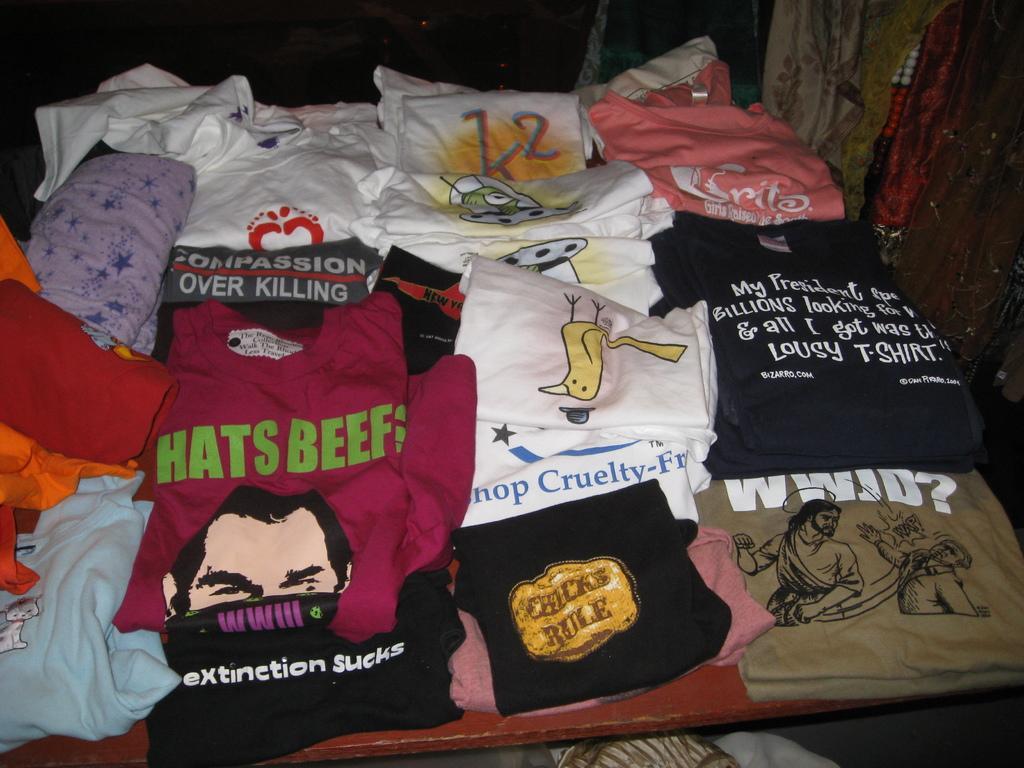Please provide a concise description of this image. In this picture there are few T-shirts which are in different colors are placed on an object. 